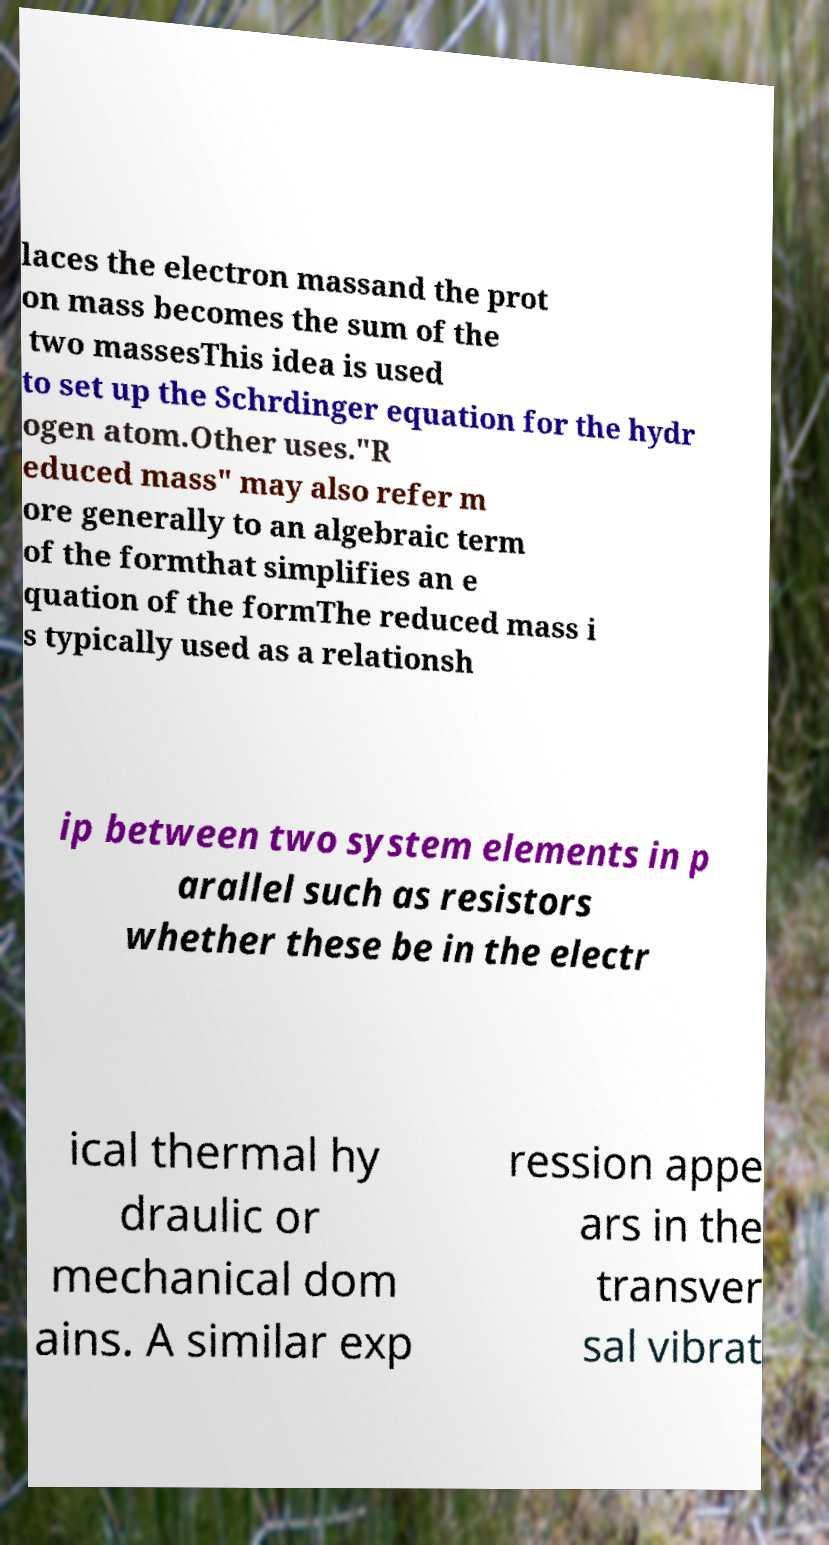Can you accurately transcribe the text from the provided image for me? laces the electron massand the prot on mass becomes the sum of the two massesThis idea is used to set up the Schrdinger equation for the hydr ogen atom.Other uses."R educed mass" may also refer m ore generally to an algebraic term of the formthat simplifies an e quation of the formThe reduced mass i s typically used as a relationsh ip between two system elements in p arallel such as resistors whether these be in the electr ical thermal hy draulic or mechanical dom ains. A similar exp ression appe ars in the transver sal vibrat 